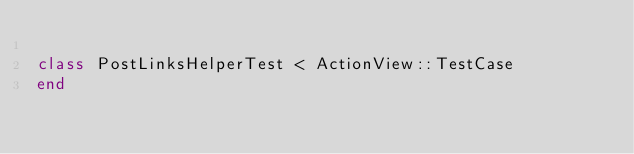<code> <loc_0><loc_0><loc_500><loc_500><_Ruby_>
class PostLinksHelperTest < ActionView::TestCase
end
</code> 